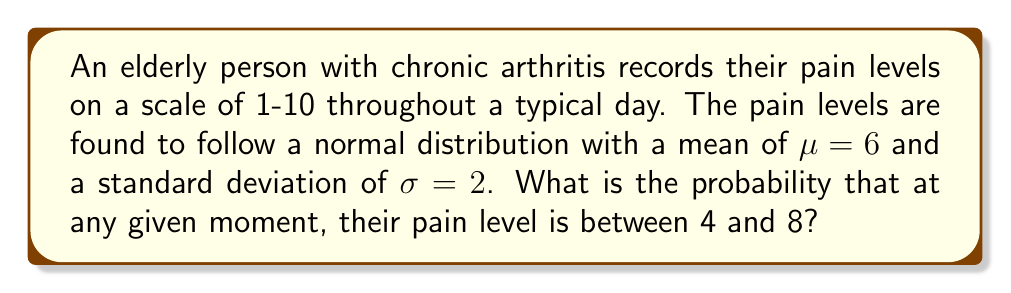Give your solution to this math problem. To solve this problem, we need to use the properties of the normal distribution and the concept of z-scores.

1. First, we need to standardize the given range (4 to 8) using the z-score formula:

   $$z = \frac{x - \mu}{\sigma}$$

   For x = 4: $z_1 = \frac{4 - 6}{2} = -1$
   For x = 8: $z_2 = \frac{8 - 6}{2} = 1$

2. Now, we need to find the area under the standard normal curve between z = -1 and z = 1.

3. Using a standard normal distribution table or calculator, we can find:
   P(Z ≤ 1) = 0.8413
   P(Z ≤ -1) = 0.1587

4. The probability we're looking for is the difference between these two values:

   P(-1 < Z < 1) = P(Z < 1) - P(Z < -1)
                 = 0.8413 - 0.1587
                 = 0.6826

5. Therefore, the probability that the pain level is between 4 and 8 at any given moment is approximately 0.6826 or 68.26%.
Answer: 0.6826 or 68.26% 